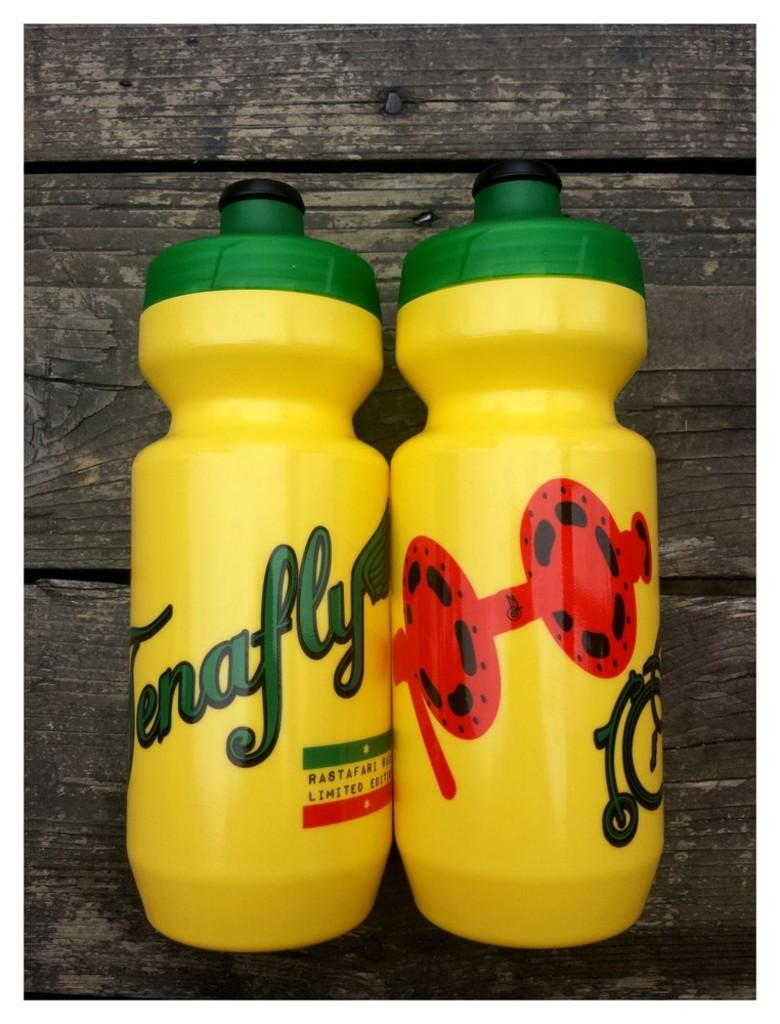Provide a one-sentence caption for the provided image. A decorated yellow and green bottle that reads Tenafly. 